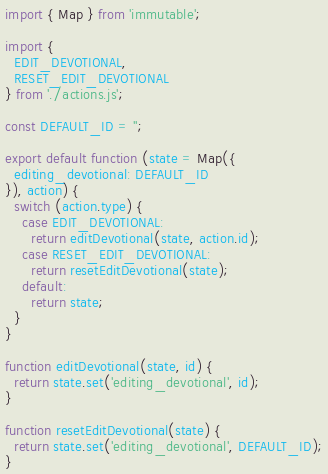Convert code to text. <code><loc_0><loc_0><loc_500><loc_500><_JavaScript_>import { Map } from 'immutable';

import {
  EDIT_DEVOTIONAL,
  RESET_EDIT_DEVOTIONAL
} from './actions.js';

const DEFAULT_ID = '';

export default function (state = Map({
  editing_devotional: DEFAULT_ID
}), action) {
  switch (action.type) {
    case EDIT_DEVOTIONAL:
      return editDevotional(state, action.id);
    case RESET_EDIT_DEVOTIONAL:
      return resetEditDevotional(state);
    default:
      return state;
  }
}

function editDevotional(state, id) {
  return state.set('editing_devotional', id);
}

function resetEditDevotional(state) {
  return state.set('editing_devotional', DEFAULT_ID);
}</code> 